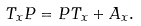<formula> <loc_0><loc_0><loc_500><loc_500>T _ { x } P = P T _ { x } + A _ { x } .</formula> 